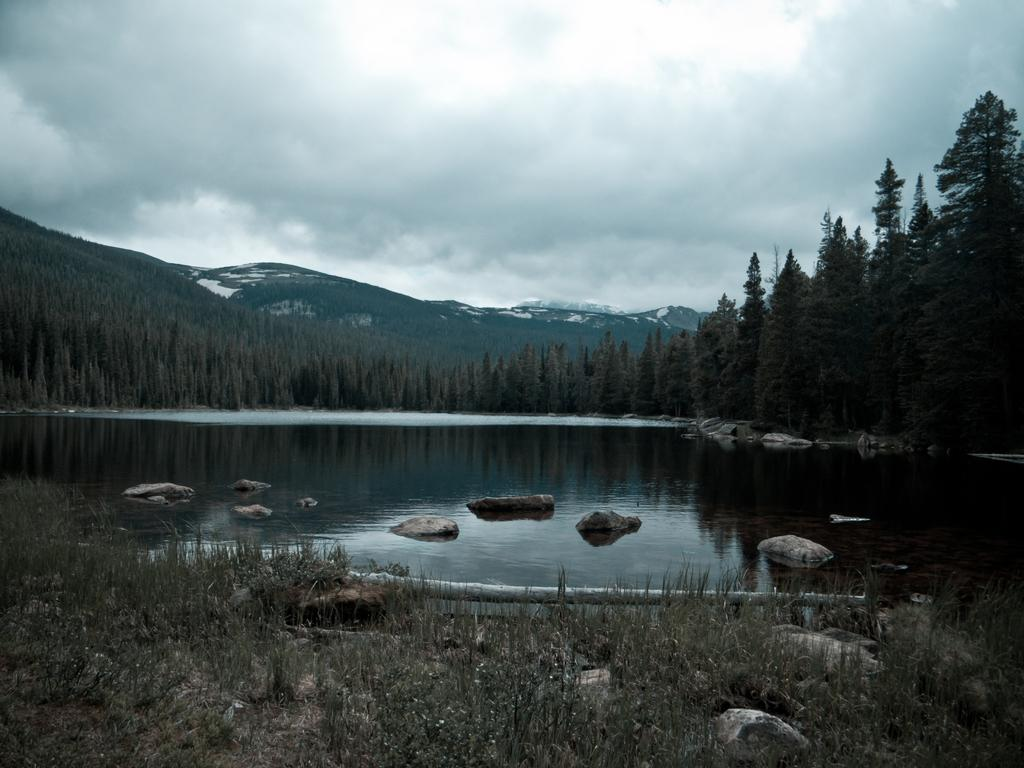What is the primary element present in the image? There is water in the image. What can be found within the water? There are stones in the water. What type of vegetation is visible in the background of the image? There are trees in the background of the image, and they are green. What type of landscape feature is visible in the background of the image? There are mountains in the background of the image. What is the color of the sky in the image? The sky is white in color. What type of picture is hanging on the wall in the image? There is no mention of a wall or a picture hanging on it in the provided facts, so we cannot answer this question. --- Facts: 1. There is a person sitting on a chair in the image. 2. The person is holding a book. 3. The book has a blue cover. 4. There is a table next to the chair. 5. There is a lamp on the table. Absurd Topics: parrot, ocean, dance Conversation: What is the person in the image doing? The person is sitting on a chair in the image. What is the person holding? The person is holding a book. What color is the book's cover? The book has a blue cover. What is located next to the chair? There is a table next to the chair. What object is on the table? There is a lamp on the table. Reasoning: Let's think step by step in order to produce the conversation. We start by identifying the main subject in the image, which is the person sitting on a chair. Then, we describe what the person is holding, which is a book with a blue cover. Next, we mention the presence of a table next to the chair and a lamp on the table. Each question is designed to elicit a specific detail about the image that is known from the provided facts. Absurd Question/Answer: Can you tell me how many parrots are sitting on the person's shoulder in the image? There is no mention of a parrot or any animal in the provided facts, so we cannot answer this question. 